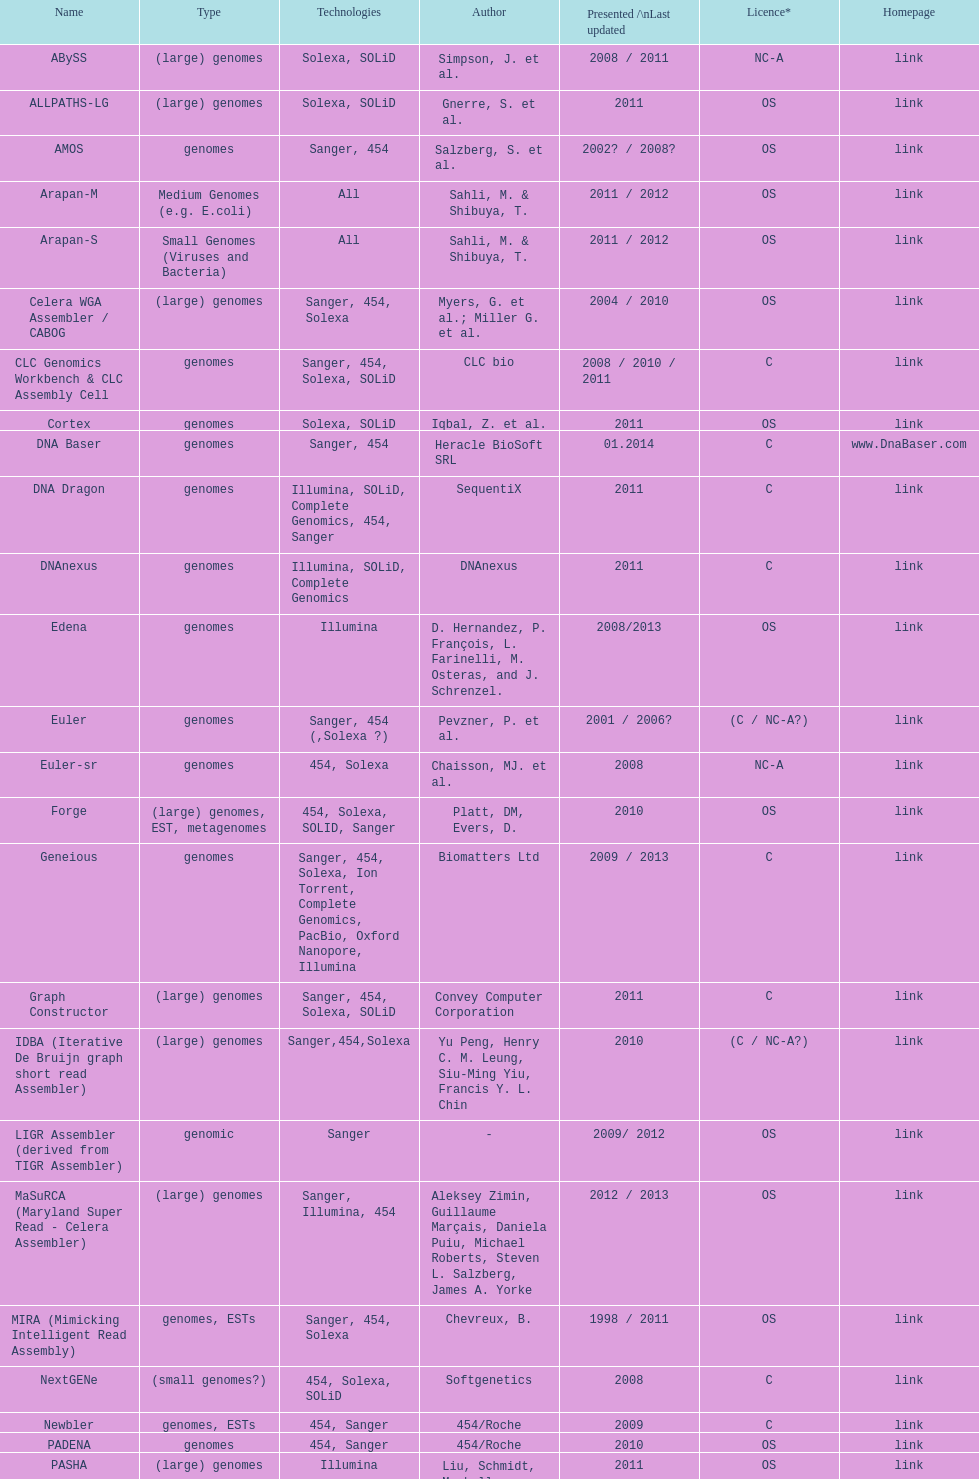When was the velvet last updated? 2009. 